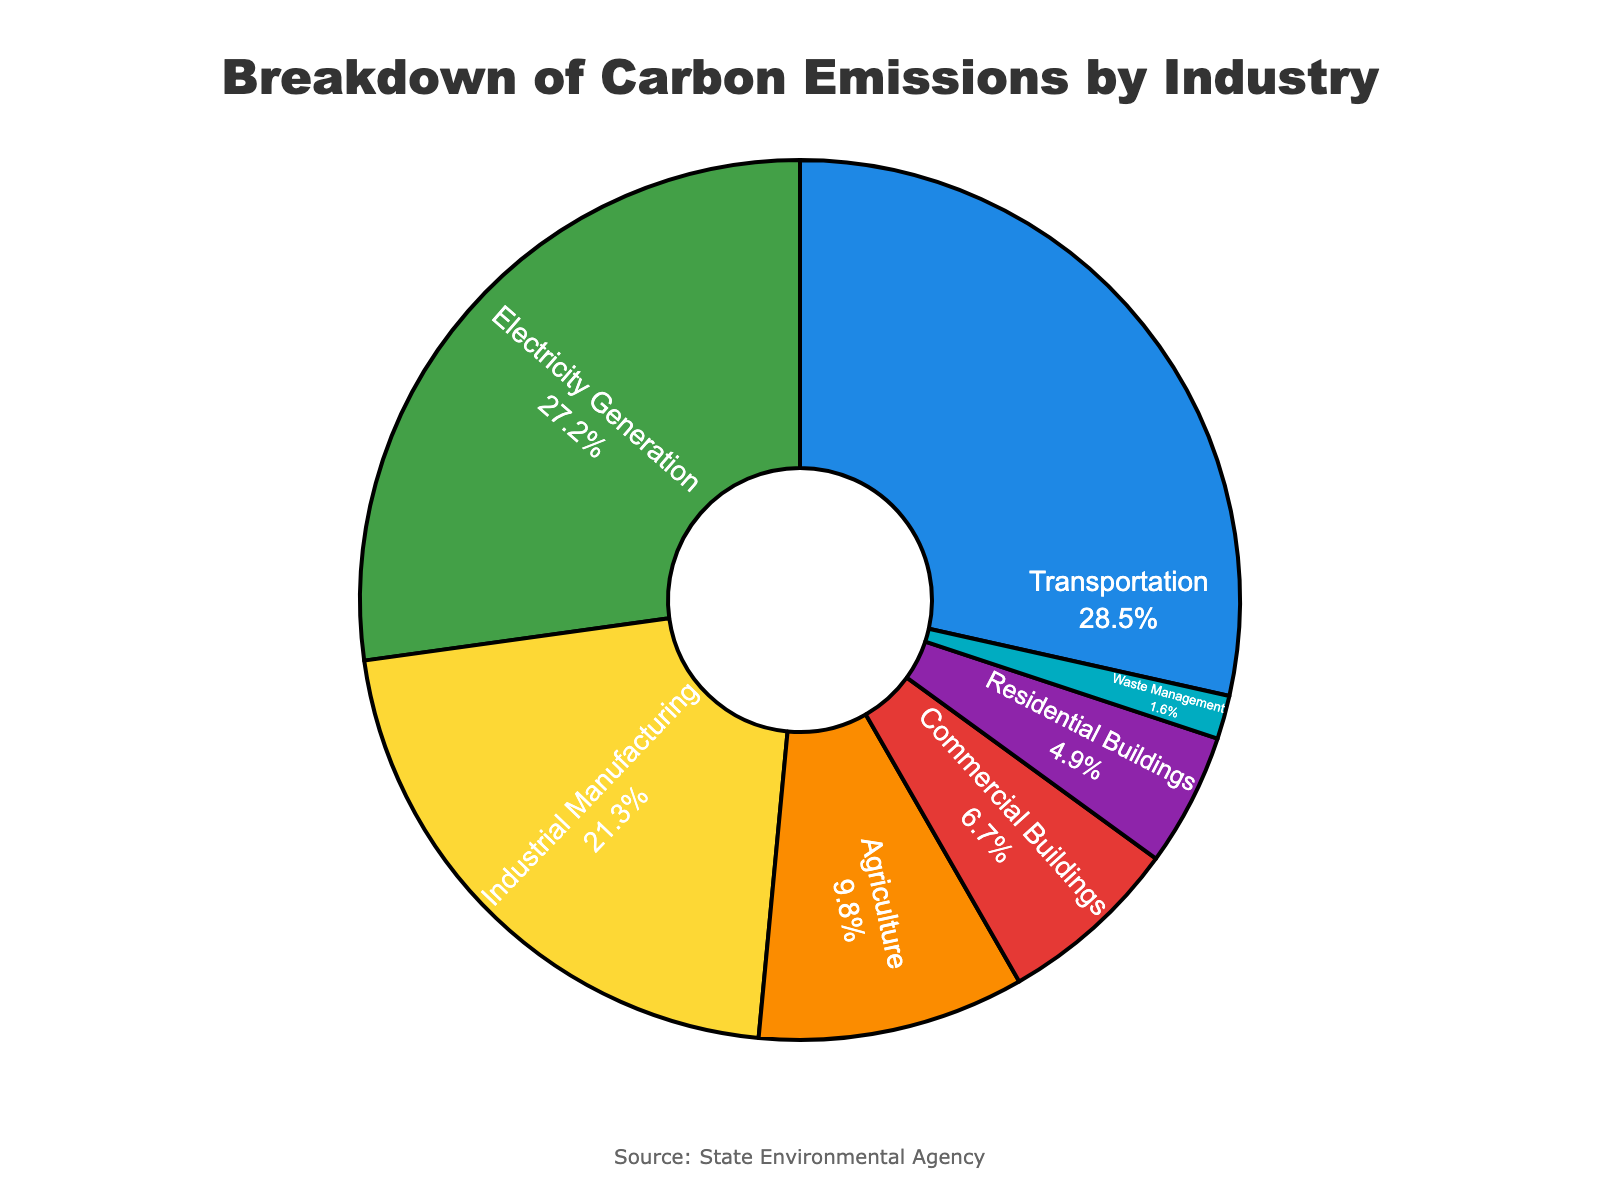What percentage of carbon emissions come from Transportation and Electricity Generation combined? Add the percentage of carbon emissions from Transportation (28.5%) and Electricity Generation (27.2%): 28.5% + 27.2% = 55.7%
Answer: 55.7% Which two industries have the highest carbon emissions? Transportation and Electricity Generation have the highest carbon emissions, contributing 28.5% and 27.2%, respectively.
Answer: Transportation and Electricity Generation Which industry has the lowest carbon emissions, and what is its percentage share? The industry with the lowest carbon emissions is Waste Management, with a 1.6% share.
Answer: Waste Management, 1.6% Is the percentage of carbon emissions from Residential Buildings greater or less than that from Commercial Buildings? The percentage of carbon emissions from Residential Buildings (4.9%) is less than that from Commercial Buildings (6.7%).
Answer: Less What is the combined percentage of carbon emissions from Industrial Manufacturing and Agriculture? Adding the carbon emissions from Industrial Manufacturing (21.3%) and Agriculture (9.8%): 21.3% + 9.8% = 31.1%
Answer: 31.1% Out of the given industries, which one contributes nearly one-fourth of the total carbon emissions? Electricity Generation contributes 27.2% of the total carbon emissions, which is nearly one-fourth.
Answer: Electricity Generation Are the combined emissions from Residential Buildings and Waste Management more than 6.0%? Adding the carbon emissions from Residential Buildings (4.9%) and Waste Management (1.6%) results in 4.9% + 1.6% = 6.5%, which is more than 6.0%.
Answer: Yes How many industries contribute less than 10% each to the total carbon emissions? The industries contributing less than 10% each are Agriculture (9.8%), Commercial Buildings (6.7%), Residential Buildings (4.9%), and Waste Management (1.6%), totaling four industries.
Answer: Four What would be the combined percentage of all industries except the two with the highest emissions? Adding the percentages of all industries except Transportation (28.5%) and Electricity Generation (27.2%): 21.3% + 9.8% + 6.7% + 4.9% + 1.6% = 44.3%
Answer: 44.3% What visual attribute indicates the contribution of each industry in the pie chart, and how does it help in understanding the carbon emissions breakdown? The color and size of each pie slice indicate the contribution of each industry. Larger slices represent higher emissions, and different colors make it easier to distinguish between categories.
Answer: Color and size of slices 